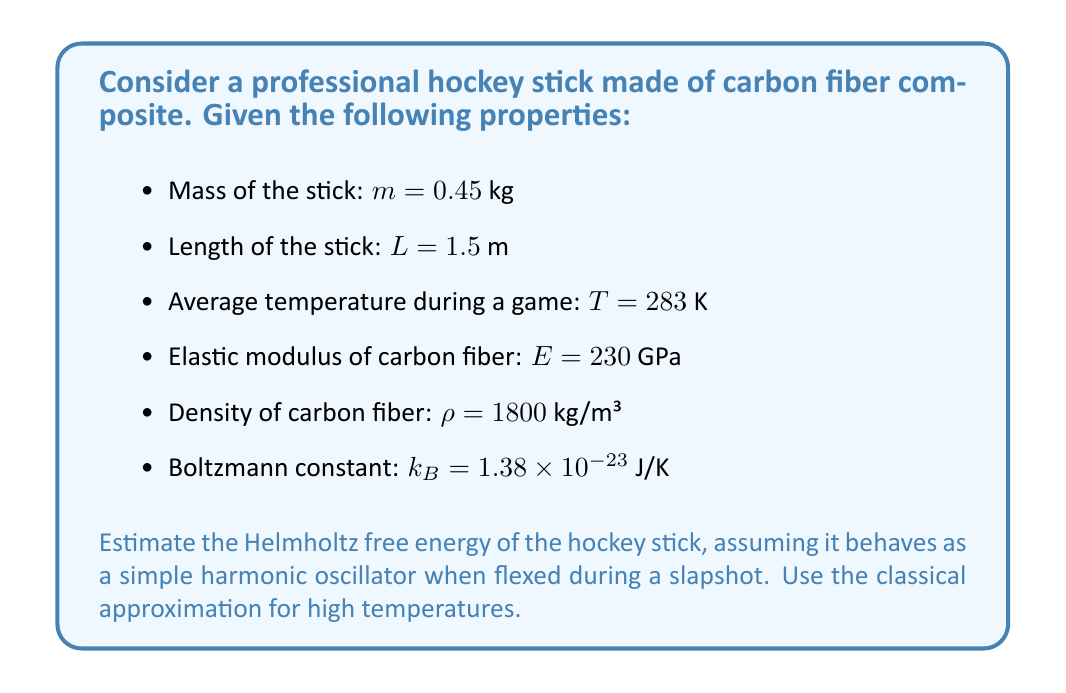What is the answer to this math problem? To estimate the Helmholtz free energy of the hockey stick, we'll follow these steps:

1) First, we need to calculate the spring constant $k$ of the stick. We can approximate this using the elastic modulus:

   $k = \frac{EA}{L}$

   where $A$ is the cross-sectional area. We can estimate $A$ using the mass and density:

   $A = \frac{m}{\rho L} = \frac{0.45}{1800 \times 1.5} = 1.667 \times 10^{-4}$ m²

   Now we can calculate $k$:

   $k = \frac{230 \times 10^9 \times 1.667 \times 10^{-4}}{1.5} = 2.556 \times 10^7$ N/m

2) For a simple harmonic oscillator, the natural frequency $\omega$ is given by:

   $\omega = \sqrt{\frac{k}{m}} = \sqrt{\frac{2.556 \times 10^7}{0.45}} = 7,534$ rad/s

3) In the classical high-temperature limit, the Helmholtz free energy $F$ for a harmonic oscillator is given by:

   $F = k_B T \ln(\frac{\hbar \omega}{k_B T})$

   where $\hbar$ is the reduced Planck constant ($1.055 \times 10^{-34}$ J·s)

4) Substituting the values:

   $F = 1.38 \times 10^{-23} \times 283 \times \ln(\frac{1.055 \times 10^{-34} \times 7,534}{1.38 \times 10^{-23} \times 283})$

5) Calculating:

   $F = -1.286 \times 10^{-20}$ J

The negative value indicates that work can be extracted from the system, which makes sense for a hockey stick that stores and releases energy during a slapshot.
Answer: $-1.286 \times 10^{-20}$ J 